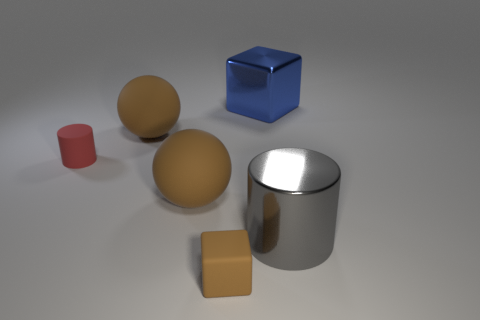Does the big block have the same material as the brown block?
Offer a very short reply. No. Are there the same number of big objects that are behind the small red rubber object and big metallic blocks?
Ensure brevity in your answer.  No. How many large gray cylinders are made of the same material as the small brown thing?
Ensure brevity in your answer.  0. Are there fewer red matte things than brown spheres?
Your answer should be compact. Yes. Is the color of the big matte sphere behind the red object the same as the tiny rubber block?
Your answer should be compact. Yes. There is a tiny thing in front of the cylinder to the right of the big blue metal thing; how many small brown rubber cubes are in front of it?
Make the answer very short. 0. What number of big brown balls are behind the tiny red matte cylinder?
Your answer should be very brief. 1. There is another large thing that is the same shape as the red object; what color is it?
Your answer should be very brief. Gray. What is the thing that is in front of the red matte thing and behind the metal cylinder made of?
Give a very brief answer. Rubber. Do the metal object that is left of the shiny cylinder and the small red matte thing have the same size?
Provide a short and direct response. No. 